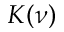<formula> <loc_0><loc_0><loc_500><loc_500>K ( \nu )</formula> 